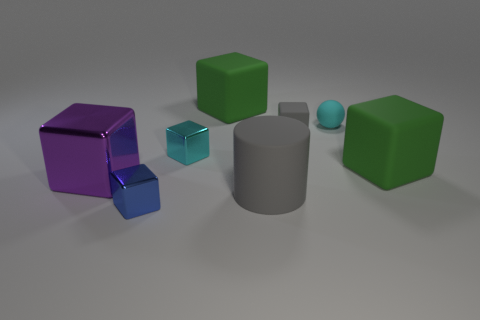There is a object that is the same color as the cylinder; what is its material?
Your answer should be very brief. Rubber. Are there any other things that have the same shape as the big gray object?
Give a very brief answer. No. Is the big cylinder that is to the right of the small cyan block made of the same material as the purple cube?
Offer a very short reply. No. How many things are either tiny yellow metal cylinders or objects to the right of the blue block?
Make the answer very short. 6. There is a tiny block that is the same material as the large cylinder; what is its color?
Keep it short and to the point. Gray. How many things are blue metal objects or purple shiny things?
Ensure brevity in your answer.  2. The ball that is the same size as the cyan metallic block is what color?
Provide a succinct answer. Cyan. What number of things are large green matte things that are on the left side of the rubber sphere or gray metal spheres?
Your answer should be very brief. 1. How many other things are there of the same size as the gray cylinder?
Give a very brief answer. 3. What size is the metallic block behind the purple shiny thing?
Provide a short and direct response. Small. 